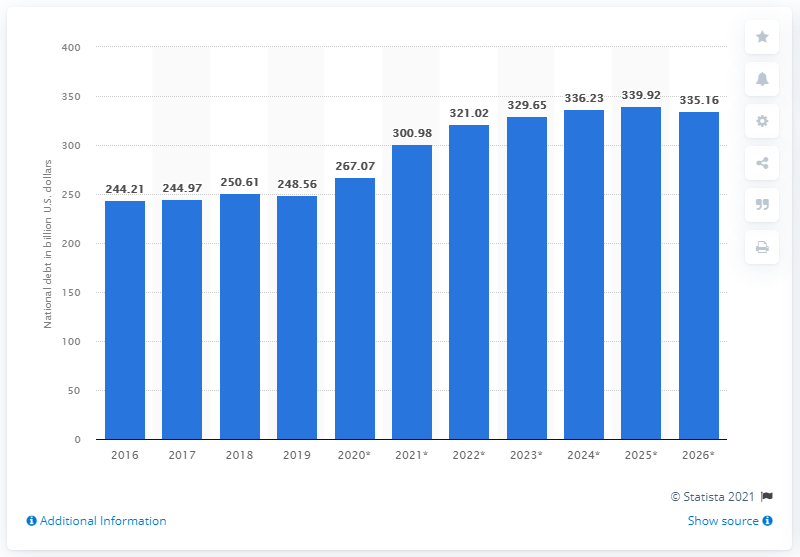Mention a couple of crucial points in this snapshot. In 2019, the national debt of Ireland was approximately 248.56 dollars. As of 2019, Greece's debt was 300.98. 